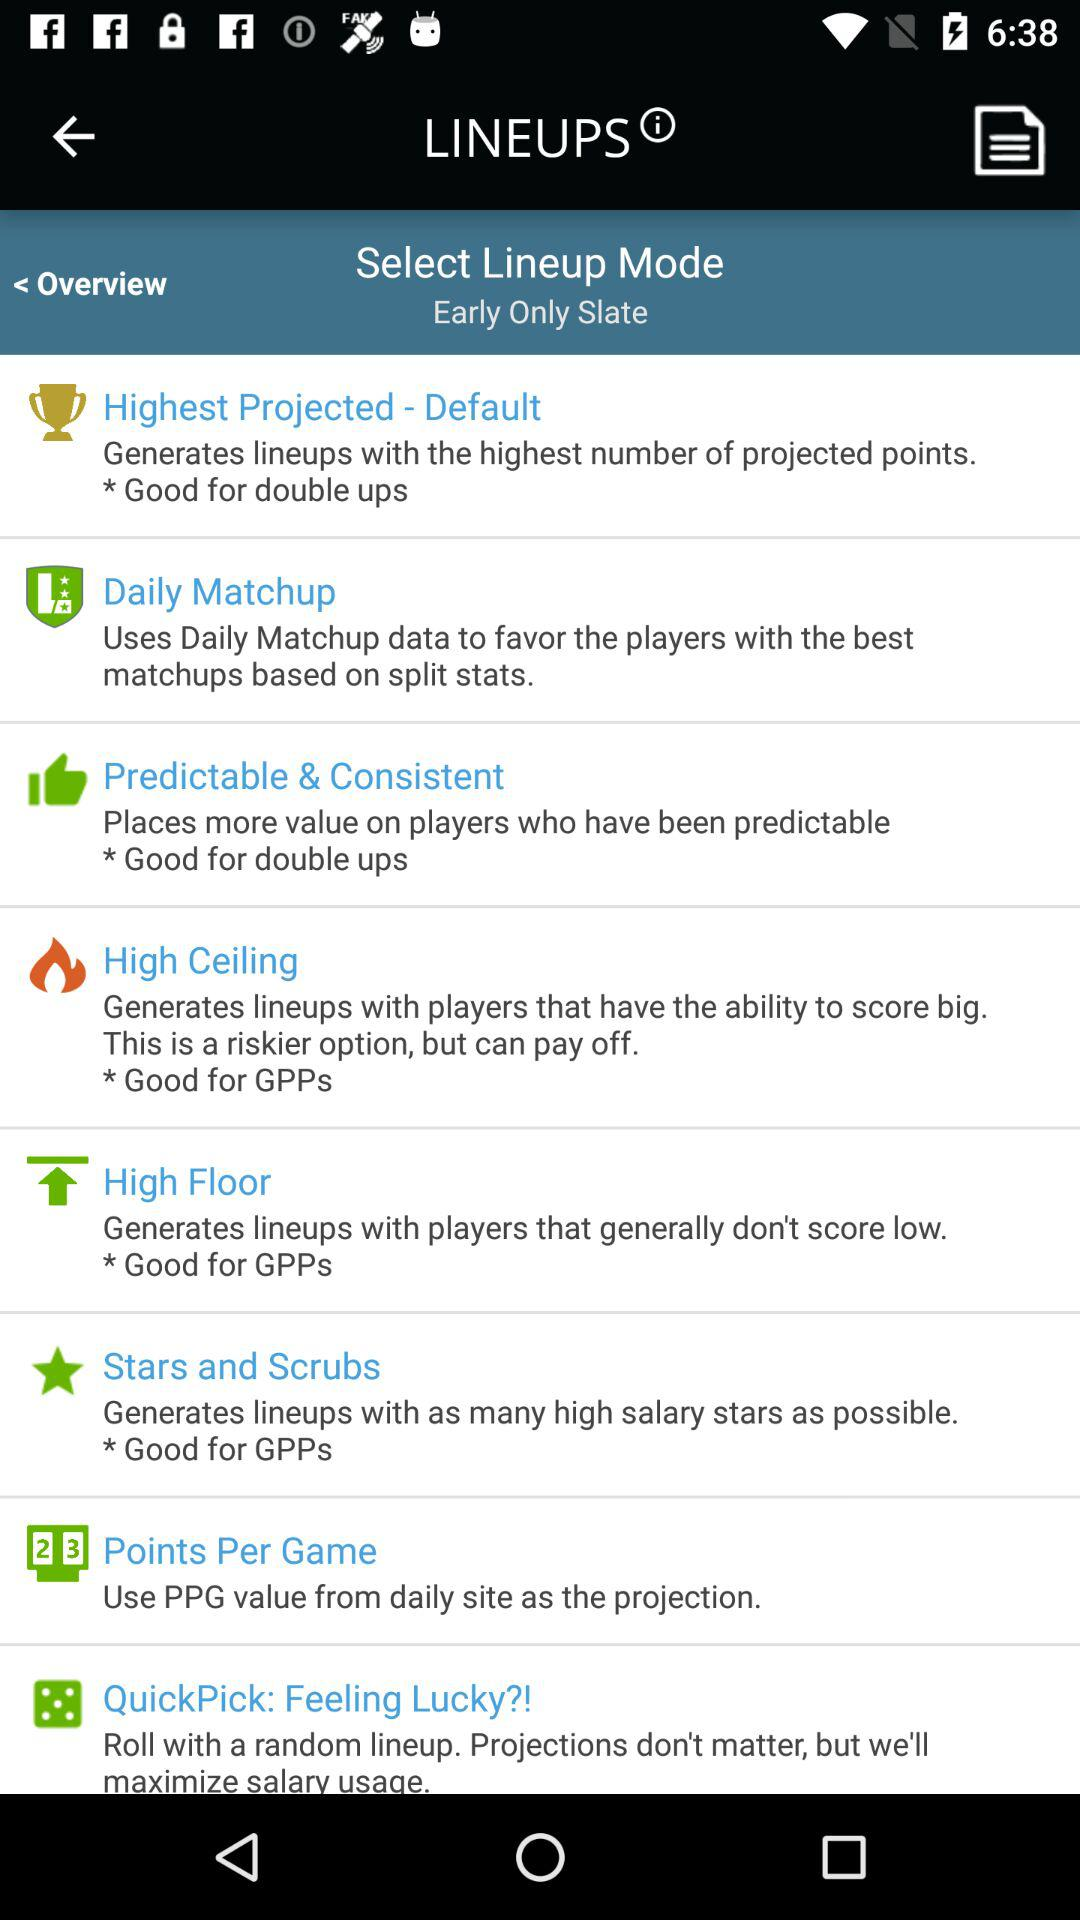What is the name of the application? The name of the application is "LINEUPS". 